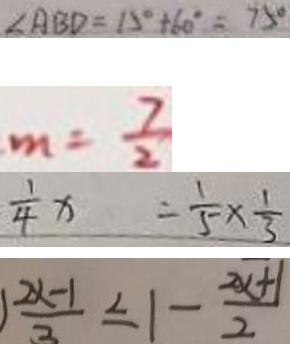<formula> <loc_0><loc_0><loc_500><loc_500>\angle A B D = 1 5 ^ { \circ } + 6 0 ^ { \circ } = 7 5 ^ { \circ } 
 m = \frac { 7 } { 2 } 
 \frac { 1 } { 4 } x = \frac { 1 } { 5 } \times \frac { 1 } { 3 } 
 1 \frac { 2 x - 1 } { 3 } \leq 1 - \frac { 2 x + 1 } { 2 }</formula> 